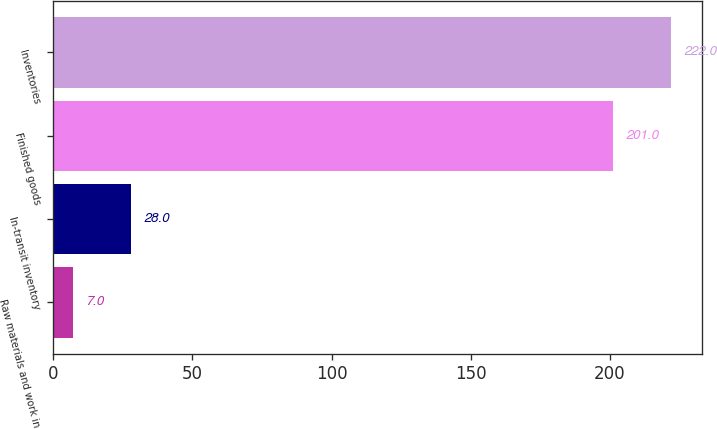Convert chart. <chart><loc_0><loc_0><loc_500><loc_500><bar_chart><fcel>Raw materials and work in<fcel>In-transit inventory<fcel>Finished goods<fcel>Inventories<nl><fcel>7<fcel>28<fcel>201<fcel>222<nl></chart> 